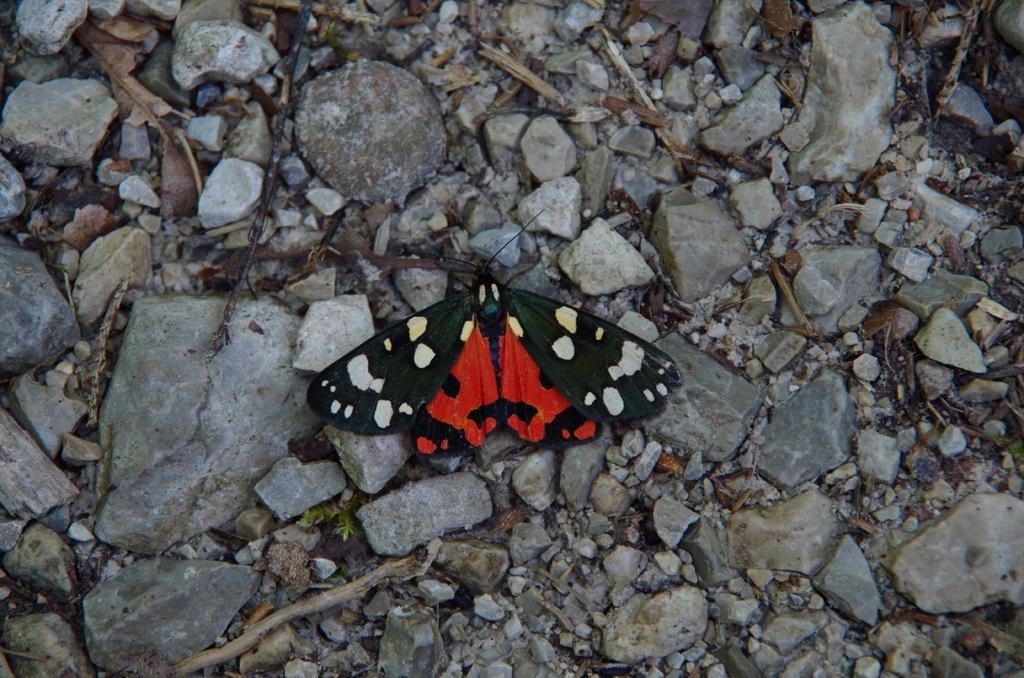Describe this image in one or two sentences. In this image there is a butterfly on the surface of the rocks and there are few wooden sticks and dry leaves. 